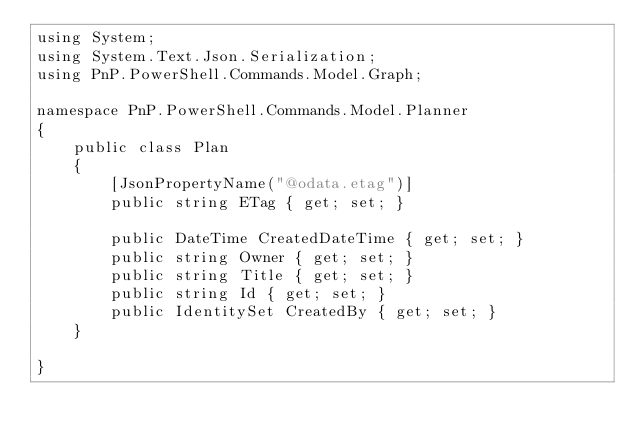<code> <loc_0><loc_0><loc_500><loc_500><_C#_>using System;
using System.Text.Json.Serialization;
using PnP.PowerShell.Commands.Model.Graph;

namespace PnP.PowerShell.Commands.Model.Planner
{
    public class Plan
    {
        [JsonPropertyName("@odata.etag")]
        public string ETag { get; set; }

        public DateTime CreatedDateTime { get; set; }
        public string Owner { get; set; }
        public string Title { get; set; }
        public string Id { get; set; }
        public IdentitySet CreatedBy { get; set; }
    }

}</code> 